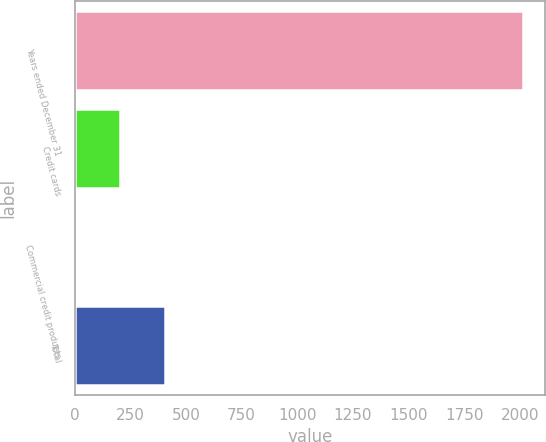<chart> <loc_0><loc_0><loc_500><loc_500><bar_chart><fcel>Years ended December 31<fcel>Credit cards<fcel>Commercial credit products<fcel>Total<nl><fcel>2015<fcel>202.4<fcel>1<fcel>403.8<nl></chart> 